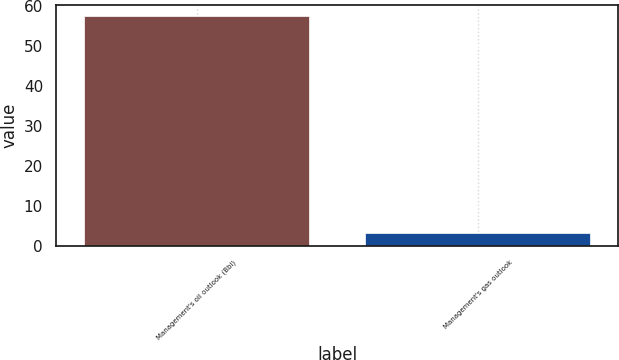Convert chart. <chart><loc_0><loc_0><loc_500><loc_500><bar_chart><fcel>Management's oil outlook (Bbl)<fcel>Management's gas outlook<nl><fcel>57.32<fcel>3.21<nl></chart> 